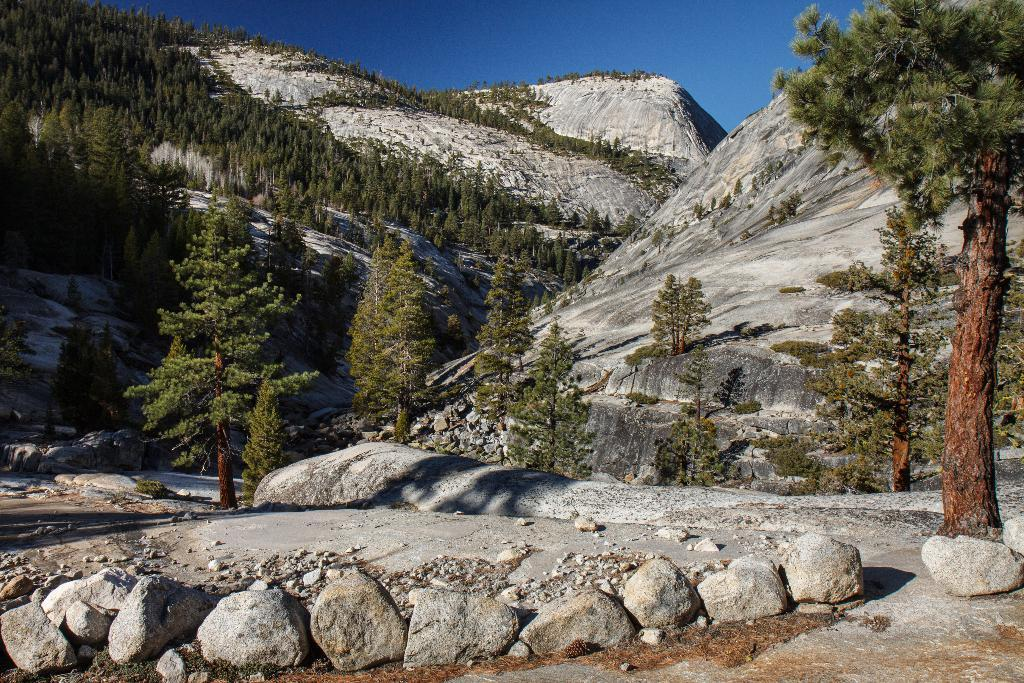What type of natural elements can be seen on the ground in the image? There are rocks and stones on the ground in the image. What type of vegetation is visible in the background? There are trees in the background of the image. What type of large landforms can be seen in the background? There are mountains in the background of the image. What color is the sky in the image? The sky is blue in the image. What language is spoken by the rocks in the image? Rocks do not speak any language, as they are inanimate objects. How many dimes can be seen on the ground in the image? There are no dimes present in the image; it features rocks and stones on the ground. 